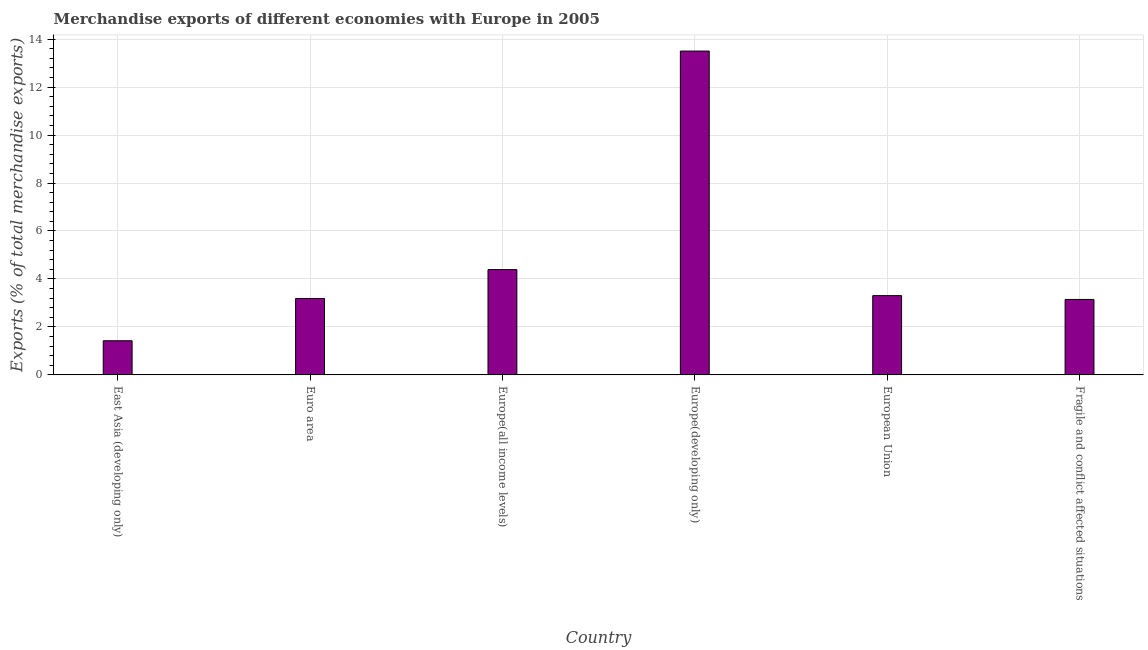Does the graph contain any zero values?
Keep it short and to the point. No. Does the graph contain grids?
Ensure brevity in your answer.  Yes. What is the title of the graph?
Your answer should be compact. Merchandise exports of different economies with Europe in 2005. What is the label or title of the Y-axis?
Keep it short and to the point. Exports (% of total merchandise exports). What is the merchandise exports in Europe(developing only)?
Offer a very short reply. 13.5. Across all countries, what is the maximum merchandise exports?
Make the answer very short. 13.5. Across all countries, what is the minimum merchandise exports?
Offer a very short reply. 1.42. In which country was the merchandise exports maximum?
Offer a terse response. Europe(developing only). In which country was the merchandise exports minimum?
Offer a terse response. East Asia (developing only). What is the sum of the merchandise exports?
Keep it short and to the point. 28.95. What is the difference between the merchandise exports in Europe(developing only) and Fragile and conflict affected situations?
Provide a succinct answer. 10.36. What is the average merchandise exports per country?
Your response must be concise. 4.83. What is the median merchandise exports?
Your answer should be compact. 3.25. What is the ratio of the merchandise exports in East Asia (developing only) to that in European Union?
Offer a terse response. 0.43. Is the merchandise exports in Europe(all income levels) less than that in Europe(developing only)?
Provide a short and direct response. Yes. Is the difference between the merchandise exports in Euro area and Fragile and conflict affected situations greater than the difference between any two countries?
Offer a very short reply. No. What is the difference between the highest and the second highest merchandise exports?
Make the answer very short. 9.11. What is the difference between the highest and the lowest merchandise exports?
Your response must be concise. 12.08. Are the values on the major ticks of Y-axis written in scientific E-notation?
Your response must be concise. No. What is the Exports (% of total merchandise exports) of East Asia (developing only)?
Provide a short and direct response. 1.42. What is the Exports (% of total merchandise exports) in Euro area?
Offer a terse response. 3.19. What is the Exports (% of total merchandise exports) of Europe(all income levels)?
Provide a short and direct response. 4.39. What is the Exports (% of total merchandise exports) of Europe(developing only)?
Ensure brevity in your answer.  13.5. What is the Exports (% of total merchandise exports) in European Union?
Offer a very short reply. 3.31. What is the Exports (% of total merchandise exports) in Fragile and conflict affected situations?
Your answer should be very brief. 3.15. What is the difference between the Exports (% of total merchandise exports) in East Asia (developing only) and Euro area?
Provide a succinct answer. -1.76. What is the difference between the Exports (% of total merchandise exports) in East Asia (developing only) and Europe(all income levels)?
Keep it short and to the point. -2.97. What is the difference between the Exports (% of total merchandise exports) in East Asia (developing only) and Europe(developing only)?
Your response must be concise. -12.08. What is the difference between the Exports (% of total merchandise exports) in East Asia (developing only) and European Union?
Make the answer very short. -1.88. What is the difference between the Exports (% of total merchandise exports) in East Asia (developing only) and Fragile and conflict affected situations?
Provide a short and direct response. -1.72. What is the difference between the Exports (% of total merchandise exports) in Euro area and Europe(all income levels)?
Keep it short and to the point. -1.2. What is the difference between the Exports (% of total merchandise exports) in Euro area and Europe(developing only)?
Offer a very short reply. -10.31. What is the difference between the Exports (% of total merchandise exports) in Euro area and European Union?
Provide a succinct answer. -0.12. What is the difference between the Exports (% of total merchandise exports) in Euro area and Fragile and conflict affected situations?
Offer a very short reply. 0.04. What is the difference between the Exports (% of total merchandise exports) in Europe(all income levels) and Europe(developing only)?
Make the answer very short. -9.11. What is the difference between the Exports (% of total merchandise exports) in Europe(all income levels) and European Union?
Your answer should be compact. 1.08. What is the difference between the Exports (% of total merchandise exports) in Europe(all income levels) and Fragile and conflict affected situations?
Offer a terse response. 1.24. What is the difference between the Exports (% of total merchandise exports) in Europe(developing only) and European Union?
Your answer should be compact. 10.2. What is the difference between the Exports (% of total merchandise exports) in Europe(developing only) and Fragile and conflict affected situations?
Ensure brevity in your answer.  10.36. What is the difference between the Exports (% of total merchandise exports) in European Union and Fragile and conflict affected situations?
Your answer should be very brief. 0.16. What is the ratio of the Exports (% of total merchandise exports) in East Asia (developing only) to that in Euro area?
Give a very brief answer. 0.45. What is the ratio of the Exports (% of total merchandise exports) in East Asia (developing only) to that in Europe(all income levels)?
Give a very brief answer. 0.32. What is the ratio of the Exports (% of total merchandise exports) in East Asia (developing only) to that in Europe(developing only)?
Keep it short and to the point. 0.1. What is the ratio of the Exports (% of total merchandise exports) in East Asia (developing only) to that in European Union?
Make the answer very short. 0.43. What is the ratio of the Exports (% of total merchandise exports) in East Asia (developing only) to that in Fragile and conflict affected situations?
Your response must be concise. 0.45. What is the ratio of the Exports (% of total merchandise exports) in Euro area to that in Europe(all income levels)?
Ensure brevity in your answer.  0.73. What is the ratio of the Exports (% of total merchandise exports) in Euro area to that in Europe(developing only)?
Ensure brevity in your answer.  0.24. What is the ratio of the Exports (% of total merchandise exports) in Euro area to that in European Union?
Provide a succinct answer. 0.96. What is the ratio of the Exports (% of total merchandise exports) in Europe(all income levels) to that in Europe(developing only)?
Offer a very short reply. 0.33. What is the ratio of the Exports (% of total merchandise exports) in Europe(all income levels) to that in European Union?
Keep it short and to the point. 1.33. What is the ratio of the Exports (% of total merchandise exports) in Europe(all income levels) to that in Fragile and conflict affected situations?
Offer a terse response. 1.4. What is the ratio of the Exports (% of total merchandise exports) in Europe(developing only) to that in European Union?
Make the answer very short. 4.08. What is the ratio of the Exports (% of total merchandise exports) in Europe(developing only) to that in Fragile and conflict affected situations?
Make the answer very short. 4.29. What is the ratio of the Exports (% of total merchandise exports) in European Union to that in Fragile and conflict affected situations?
Keep it short and to the point. 1.05. 